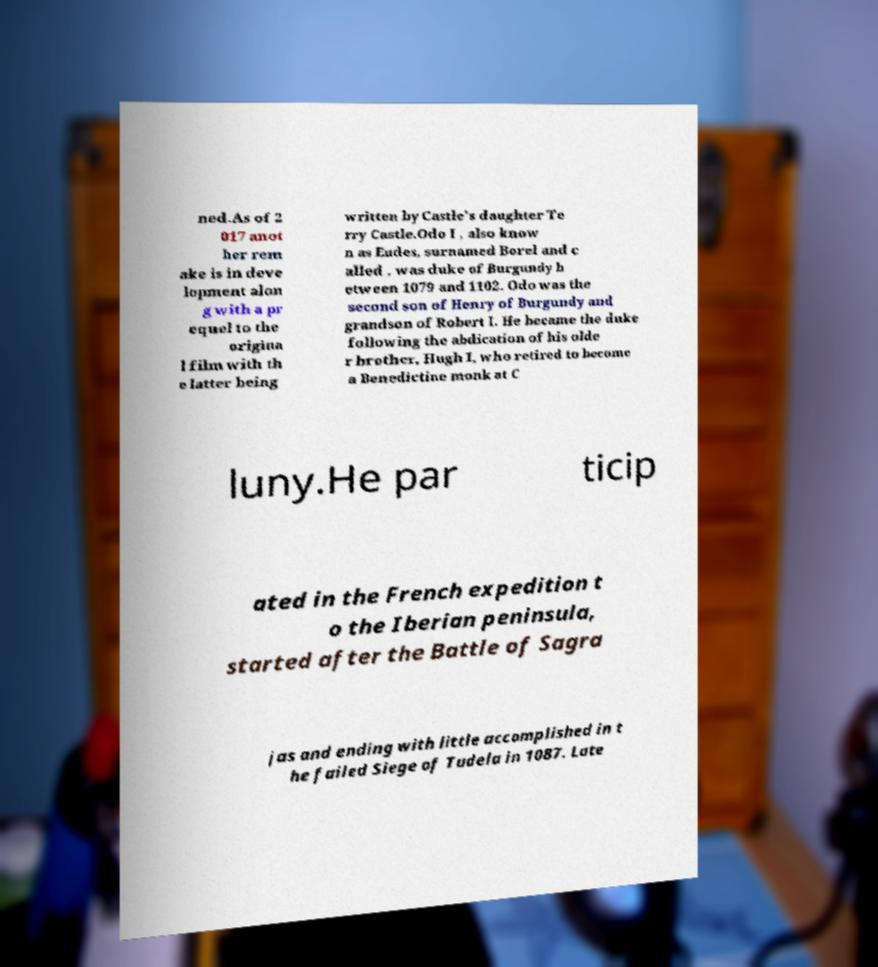Can you read and provide the text displayed in the image?This photo seems to have some interesting text. Can you extract and type it out for me? ned.As of 2 017 anot her rem ake is in deve lopment alon g with a pr equel to the origina l film with th e latter being written by Castle's daughter Te rry Castle.Odo I , also know n as Eudes, surnamed Borel and c alled , was duke of Burgundy b etween 1079 and 1102. Odo was the second son of Henry of Burgundy and grandson of Robert I. He became the duke following the abdication of his olde r brother, Hugh I, who retired to become a Benedictine monk at C luny.He par ticip ated in the French expedition t o the Iberian peninsula, started after the Battle of Sagra jas and ending with little accomplished in t he failed Siege of Tudela in 1087. Late 